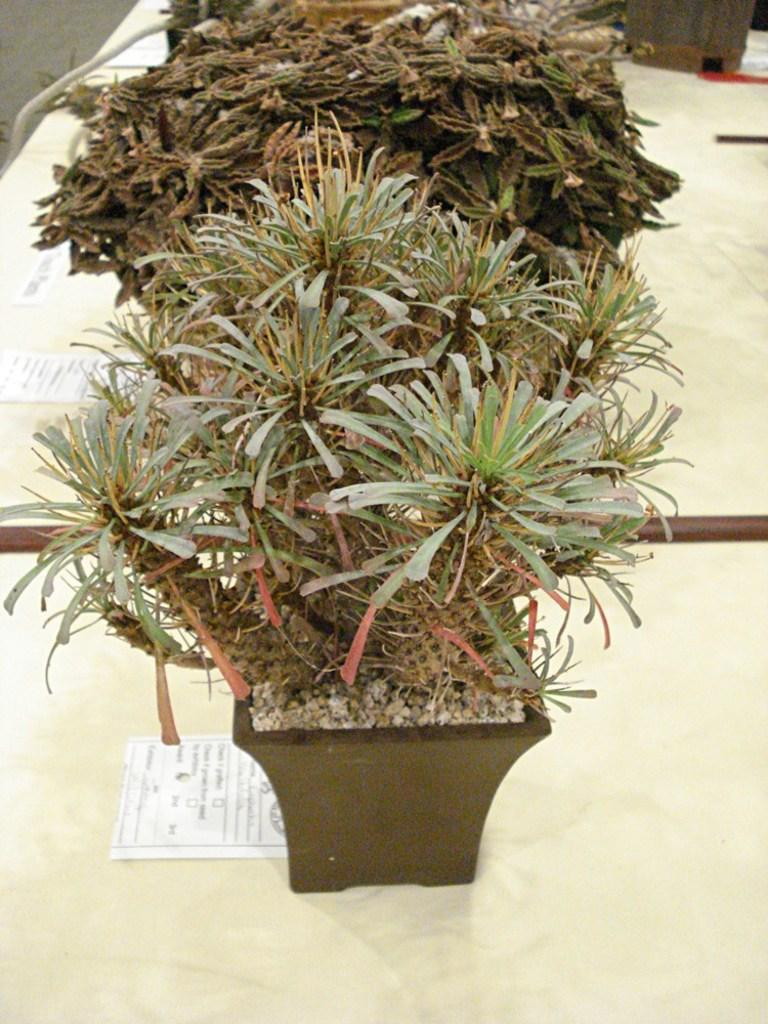What type of living organisms can be seen in the image? Plants can be seen in the image. How are some of the plants positioned in the image? One of the plants is in a pot. What type of inanimate objects are present in the image? There are stones and tables with objects in the image. What type of items can be found on the tables? Some of the objects on the tables are posters with text. What shape is the noise taking in the image? There is no noise present in the image, as it is a still picture. 